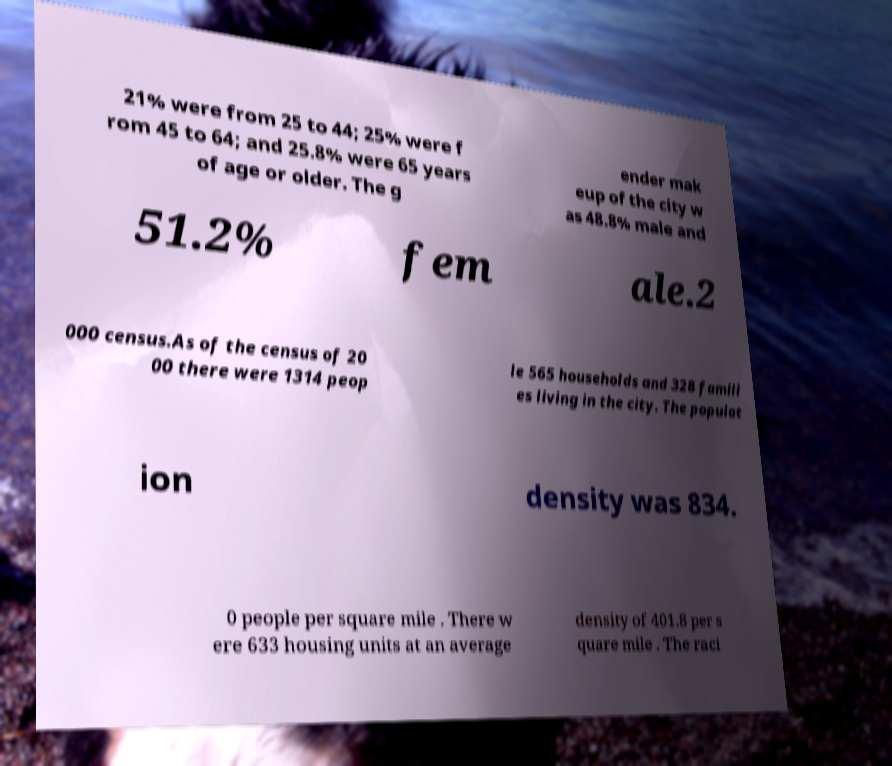There's text embedded in this image that I need extracted. Can you transcribe it verbatim? 21% were from 25 to 44; 25% were f rom 45 to 64; and 25.8% were 65 years of age or older. The g ender mak eup of the city w as 48.8% male and 51.2% fem ale.2 000 census.As of the census of 20 00 there were 1314 peop le 565 households and 328 famili es living in the city. The populat ion density was 834. 0 people per square mile . There w ere 633 housing units at an average density of 401.8 per s quare mile . The raci 